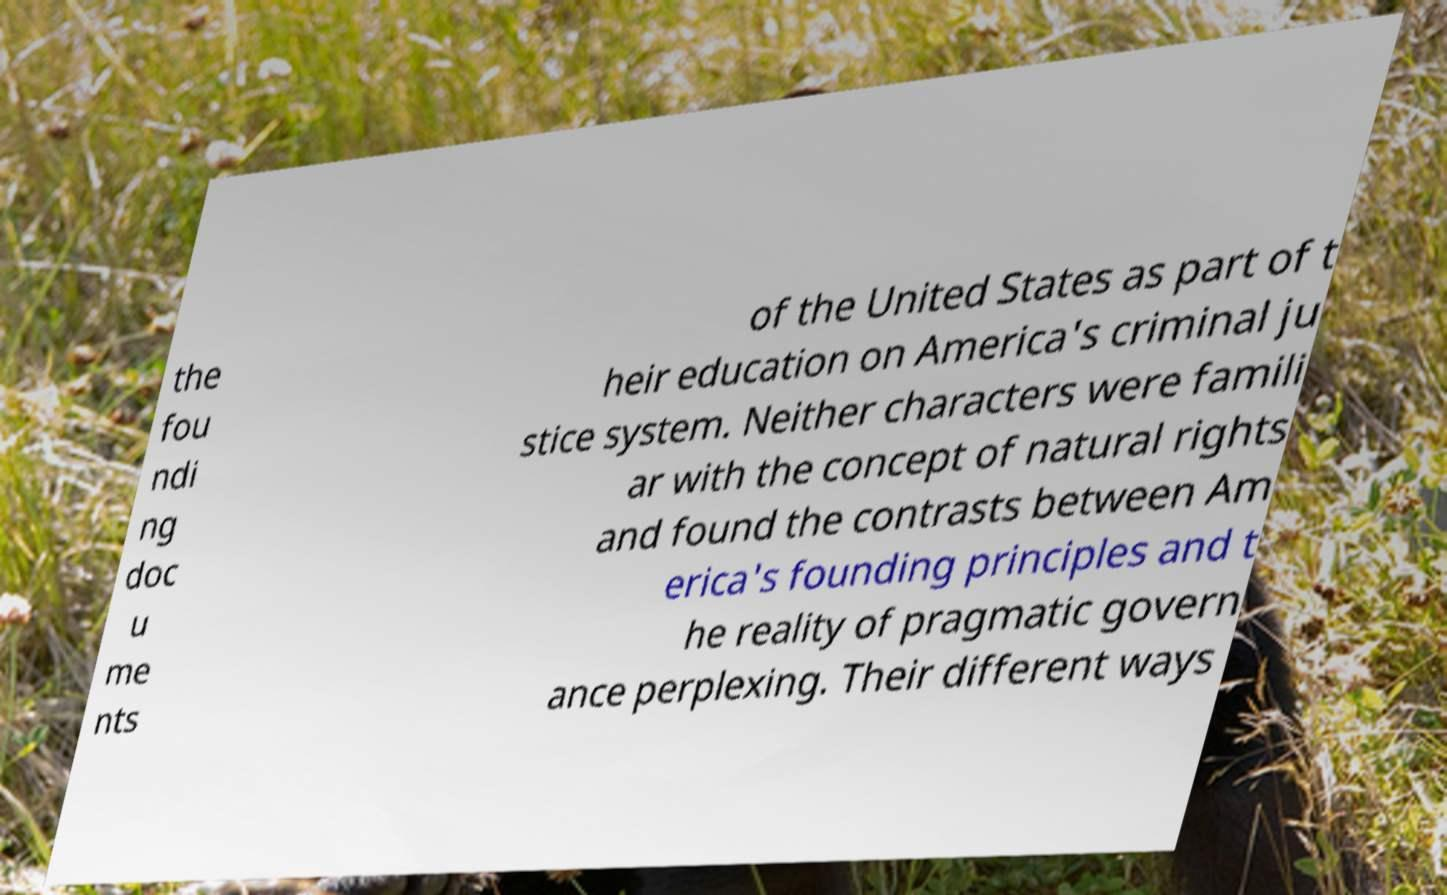Can you read and provide the text displayed in the image?This photo seems to have some interesting text. Can you extract and type it out for me? the fou ndi ng doc u me nts of the United States as part of t heir education on America's criminal ju stice system. Neither characters were famili ar with the concept of natural rights and found the contrasts between Am erica's founding principles and t he reality of pragmatic govern ance perplexing. Their different ways 